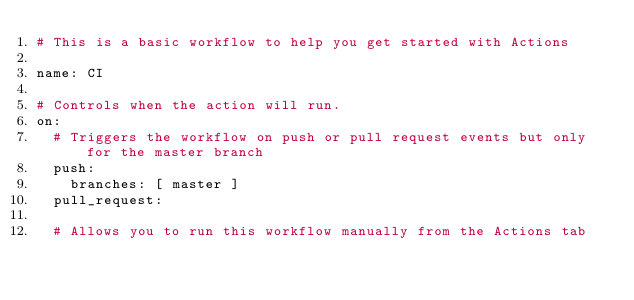Convert code to text. <code><loc_0><loc_0><loc_500><loc_500><_YAML_># This is a basic workflow to help you get started with Actions

name: CI

# Controls when the action will run. 
on:
  # Triggers the workflow on push or pull request events but only for the master branch
  push:
    branches: [ master ]
  pull_request:

  # Allows you to run this workflow manually from the Actions tab</code> 